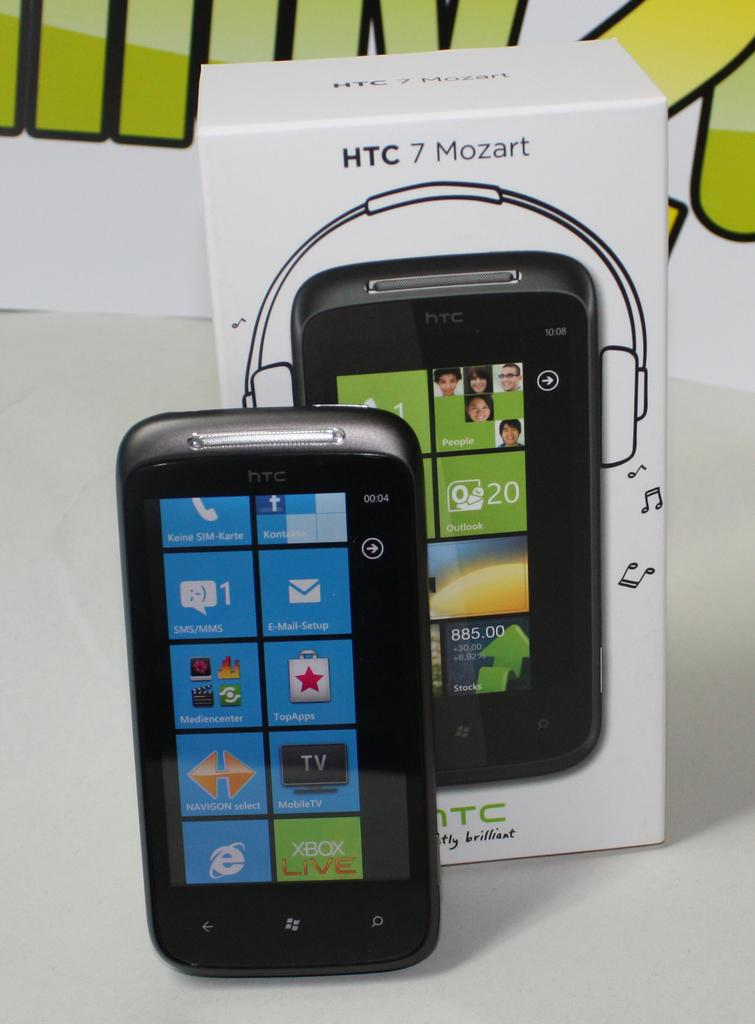What is the main object in the image? There is a mobile in the image. What is the color of the surface on which the mobile is placed? The mobile is on a white surface. What else is present on the white surface? There is a mobile box on the white surface. What can be seen in the background of the image? There is a poster in the background of the image. What type of harmony can be heard in the background of the image? There is no sound or music present in the image, so it is not possible to determine if there is any harmony. 